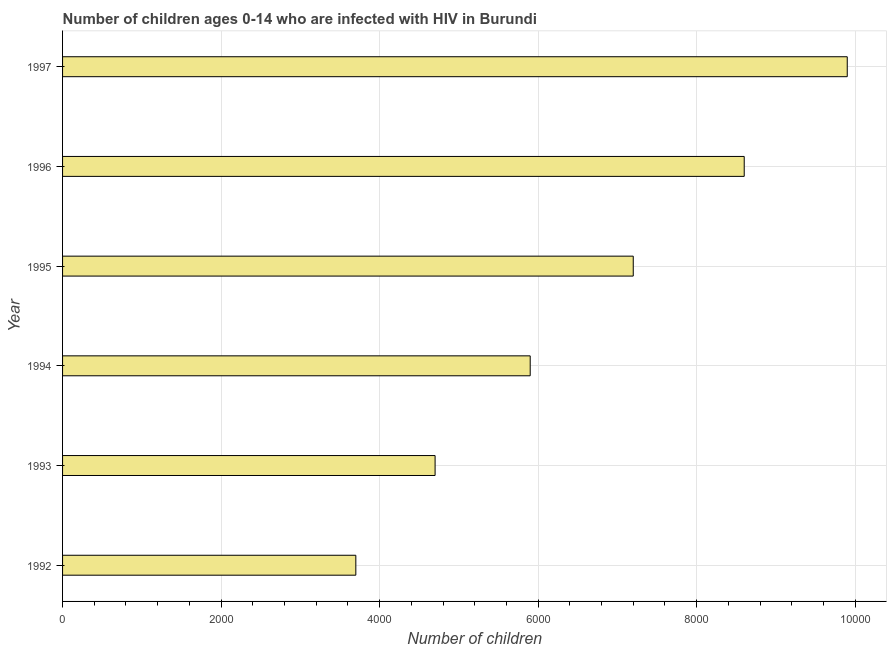Does the graph contain any zero values?
Your response must be concise. No. What is the title of the graph?
Give a very brief answer. Number of children ages 0-14 who are infected with HIV in Burundi. What is the label or title of the X-axis?
Keep it short and to the point. Number of children. What is the number of children living with hiv in 1994?
Offer a terse response. 5900. Across all years, what is the maximum number of children living with hiv?
Your answer should be very brief. 9900. Across all years, what is the minimum number of children living with hiv?
Make the answer very short. 3700. In which year was the number of children living with hiv maximum?
Your response must be concise. 1997. In which year was the number of children living with hiv minimum?
Offer a very short reply. 1992. What is the difference between the number of children living with hiv in 1993 and 1994?
Your answer should be compact. -1200. What is the average number of children living with hiv per year?
Provide a short and direct response. 6666. What is the median number of children living with hiv?
Offer a terse response. 6550. In how many years, is the number of children living with hiv greater than 6000 ?
Ensure brevity in your answer.  3. Do a majority of the years between 1995 and 1997 (inclusive) have number of children living with hiv greater than 5600 ?
Give a very brief answer. Yes. What is the ratio of the number of children living with hiv in 1992 to that in 1997?
Give a very brief answer. 0.37. Is the number of children living with hiv in 1992 less than that in 1995?
Offer a terse response. Yes. Is the difference between the number of children living with hiv in 1992 and 1993 greater than the difference between any two years?
Give a very brief answer. No. What is the difference between the highest and the second highest number of children living with hiv?
Offer a very short reply. 1300. What is the difference between the highest and the lowest number of children living with hiv?
Provide a succinct answer. 6200. In how many years, is the number of children living with hiv greater than the average number of children living with hiv taken over all years?
Offer a very short reply. 3. How many bars are there?
Keep it short and to the point. 6. Are all the bars in the graph horizontal?
Ensure brevity in your answer.  Yes. What is the difference between two consecutive major ticks on the X-axis?
Your response must be concise. 2000. What is the Number of children of 1992?
Offer a terse response. 3700. What is the Number of children in 1993?
Ensure brevity in your answer.  4700. What is the Number of children in 1994?
Provide a short and direct response. 5900. What is the Number of children of 1995?
Keep it short and to the point. 7200. What is the Number of children of 1996?
Keep it short and to the point. 8600. What is the Number of children of 1997?
Offer a very short reply. 9900. What is the difference between the Number of children in 1992 and 1993?
Ensure brevity in your answer.  -1000. What is the difference between the Number of children in 1992 and 1994?
Your answer should be compact. -2200. What is the difference between the Number of children in 1992 and 1995?
Your answer should be very brief. -3500. What is the difference between the Number of children in 1992 and 1996?
Your response must be concise. -4900. What is the difference between the Number of children in 1992 and 1997?
Ensure brevity in your answer.  -6200. What is the difference between the Number of children in 1993 and 1994?
Make the answer very short. -1200. What is the difference between the Number of children in 1993 and 1995?
Offer a very short reply. -2500. What is the difference between the Number of children in 1993 and 1996?
Ensure brevity in your answer.  -3900. What is the difference between the Number of children in 1993 and 1997?
Your response must be concise. -5200. What is the difference between the Number of children in 1994 and 1995?
Offer a very short reply. -1300. What is the difference between the Number of children in 1994 and 1996?
Your answer should be very brief. -2700. What is the difference between the Number of children in 1994 and 1997?
Offer a terse response. -4000. What is the difference between the Number of children in 1995 and 1996?
Keep it short and to the point. -1400. What is the difference between the Number of children in 1995 and 1997?
Give a very brief answer. -2700. What is the difference between the Number of children in 1996 and 1997?
Offer a very short reply. -1300. What is the ratio of the Number of children in 1992 to that in 1993?
Ensure brevity in your answer.  0.79. What is the ratio of the Number of children in 1992 to that in 1994?
Offer a very short reply. 0.63. What is the ratio of the Number of children in 1992 to that in 1995?
Your answer should be very brief. 0.51. What is the ratio of the Number of children in 1992 to that in 1996?
Offer a very short reply. 0.43. What is the ratio of the Number of children in 1992 to that in 1997?
Ensure brevity in your answer.  0.37. What is the ratio of the Number of children in 1993 to that in 1994?
Your response must be concise. 0.8. What is the ratio of the Number of children in 1993 to that in 1995?
Ensure brevity in your answer.  0.65. What is the ratio of the Number of children in 1993 to that in 1996?
Provide a succinct answer. 0.55. What is the ratio of the Number of children in 1993 to that in 1997?
Ensure brevity in your answer.  0.47. What is the ratio of the Number of children in 1994 to that in 1995?
Your answer should be compact. 0.82. What is the ratio of the Number of children in 1994 to that in 1996?
Your response must be concise. 0.69. What is the ratio of the Number of children in 1994 to that in 1997?
Your response must be concise. 0.6. What is the ratio of the Number of children in 1995 to that in 1996?
Your answer should be very brief. 0.84. What is the ratio of the Number of children in 1995 to that in 1997?
Provide a short and direct response. 0.73. What is the ratio of the Number of children in 1996 to that in 1997?
Provide a succinct answer. 0.87. 